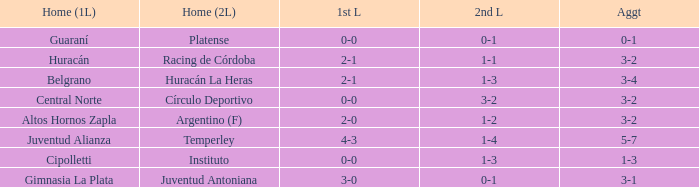Which squad competed in the 2nd leg at home with a draw of 1-1 and achieved a 3-2 total score? Racing de Córdoba. 